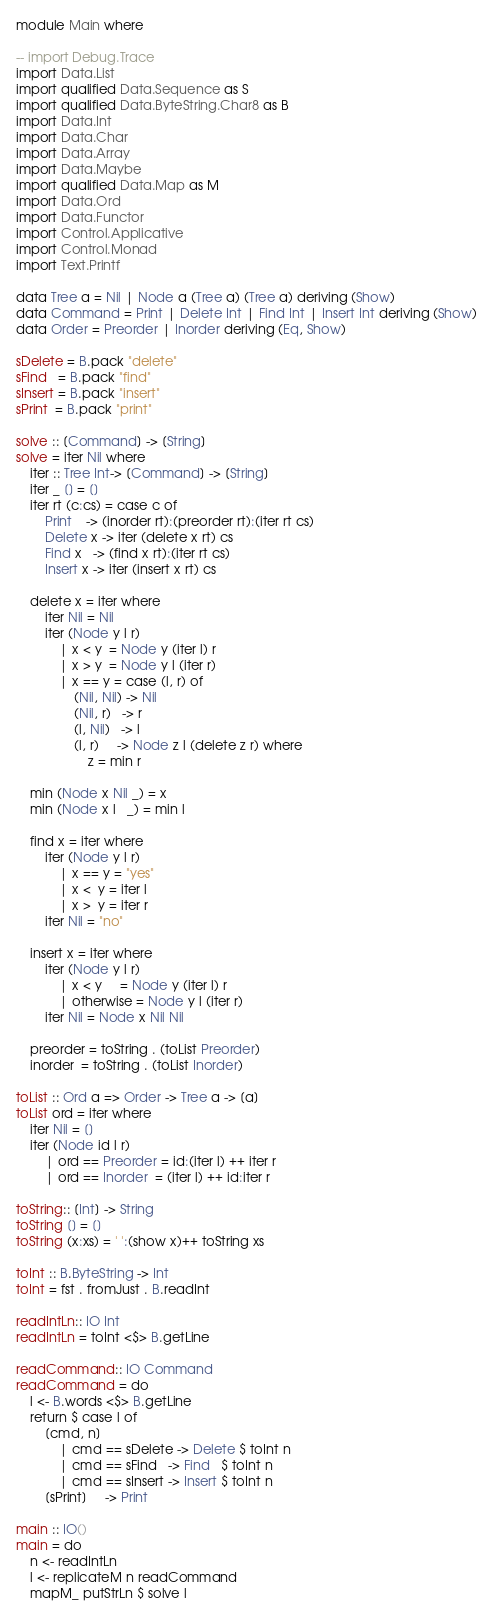Convert code to text. <code><loc_0><loc_0><loc_500><loc_500><_Haskell_>module Main where

-- import Debug.Trace
import Data.List
import qualified Data.Sequence as S
import qualified Data.ByteString.Char8 as B
import Data.Int
import Data.Char
import Data.Array
import Data.Maybe
import qualified Data.Map as M
import Data.Ord
import Data.Functor
import Control.Applicative
import Control.Monad
import Text.Printf

data Tree a = Nil | Node a (Tree a) (Tree a) deriving (Show)
data Command = Print | Delete Int | Find Int | Insert Int deriving (Show)
data Order = Preorder | Inorder deriving (Eq, Show)

sDelete = B.pack "delete"
sFind   = B.pack "find"
sInsert = B.pack "insert"
sPrint  = B.pack "print"

solve :: [Command] -> [String]
solve = iter Nil where
    iter :: Tree Int-> [Command] -> [String]
    iter _ [] = []
    iter rt (c:cs) = case c of
        Print    -> (inorder rt):(preorder rt):(iter rt cs)
        Delete x -> iter (delete x rt) cs
        Find x   -> (find x rt):(iter rt cs)
        Insert x -> iter (insert x rt) cs

    delete x = iter where
        iter Nil = Nil 
        iter (Node y l r)             
            | x < y  = Node y (iter l) r
            | x > y  = Node y l (iter r)
            | x == y = case (l, r) of
                (Nil, Nil) -> Nil
                (Nil, r)   -> r
                (l, Nil)   -> l
                (l, r)     -> Node z l (delete z r) where
                    z = min r
    
    min (Node x Nil _) = x
    min (Node x l   _) = min l

    find x = iter where
        iter (Node y l r)
            | x == y = "yes"
            | x <  y = iter l
            | x >  y = iter r 
        iter Nil = "no"

    insert x = iter where
        iter (Node y l r)             
            | x < y     = Node y (iter l) r
            | otherwise = Node y l (iter r) 
        iter Nil = Node x Nil Nil 

    preorder = toString . (toList Preorder)
    inorder  = toString . (toList Inorder)

toList :: Ord a => Order -> Tree a -> [a]
toList ord = iter where
    iter Nil = []
    iter (Node id l r)
        | ord == Preorder = id:(iter l) ++ iter r
        | ord == Inorder  = (iter l) ++ id:iter r

toString:: [Int] -> String
toString [] = []
toString (x:xs) = ' ':(show x)++ toString xs

toInt :: B.ByteString -> Int
toInt = fst . fromJust . B.readInt
                    
readIntLn:: IO Int
readIntLn = toInt <$> B.getLine

readCommand:: IO Command
readCommand = do
    l <- B.words <$> B.getLine
    return $ case l of
        [cmd, n]
            | cmd == sDelete -> Delete $ toInt n
            | cmd == sFind   -> Find   $ toInt n
            | cmd == sInsert -> Insert $ toInt n
        [sPrint]     -> Print

main :: IO() 
main = do
    n <- readIntLn
    l <- replicateM n readCommand
    mapM_ putStrLn $ solve l

</code> 